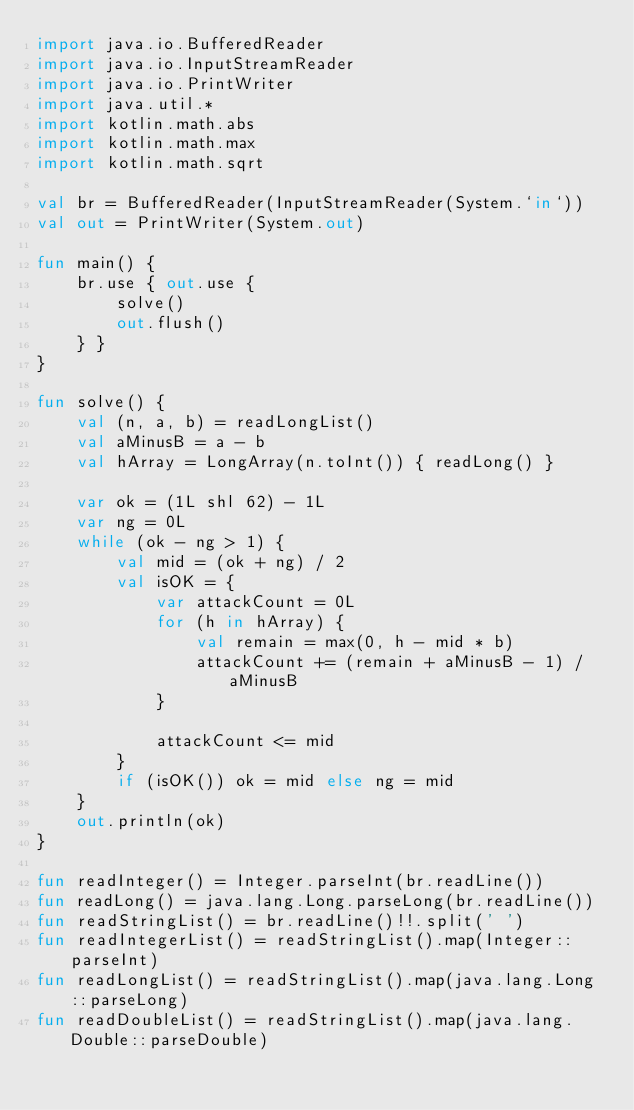<code> <loc_0><loc_0><loc_500><loc_500><_Kotlin_>import java.io.BufferedReader
import java.io.InputStreamReader
import java.io.PrintWriter
import java.util.*
import kotlin.math.abs
import kotlin.math.max
import kotlin.math.sqrt

val br = BufferedReader(InputStreamReader(System.`in`))
val out = PrintWriter(System.out)

fun main() {
    br.use { out.use {
        solve()
        out.flush()
    } }
}

fun solve() {
    val (n, a, b) = readLongList()
    val aMinusB = a - b
    val hArray = LongArray(n.toInt()) { readLong() }

    var ok = (1L shl 62) - 1L
    var ng = 0L
    while (ok - ng > 1) {
        val mid = (ok + ng) / 2
        val isOK = {
            var attackCount = 0L
            for (h in hArray) {
                val remain = max(0, h - mid * b)
                attackCount += (remain + aMinusB - 1) / aMinusB
            }

            attackCount <= mid
        }
        if (isOK()) ok = mid else ng = mid
    }
    out.println(ok)
}

fun readInteger() = Integer.parseInt(br.readLine())
fun readLong() = java.lang.Long.parseLong(br.readLine())
fun readStringList() = br.readLine()!!.split(' ')
fun readIntegerList() = readStringList().map(Integer::parseInt)
fun readLongList() = readStringList().map(java.lang.Long::parseLong)
fun readDoubleList() = readStringList().map(java.lang.Double::parseDouble)
</code> 